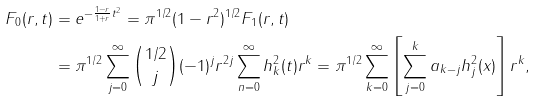Convert formula to latex. <formula><loc_0><loc_0><loc_500><loc_500>F _ { 0 } ( r , t ) & = e ^ { - \frac { 1 - r } { 1 + r } t ^ { 2 } } = \pi ^ { 1 / 2 } ( 1 - r ^ { 2 } ) ^ { 1 / 2 } F _ { 1 } ( r , t ) \\ & = \pi ^ { 1 / 2 } \sum _ { j = 0 } ^ { \infty } \binom { 1 / 2 } { j } ( - 1 ) ^ { j } r ^ { 2 j } \sum _ { n = 0 } ^ { \infty } h _ { k } ^ { 2 } ( t ) r ^ { k } = \pi ^ { 1 / 2 } \sum _ { k = 0 } ^ { \infty } \left [ \sum _ { j = 0 } ^ { k } a _ { k - j } h _ { j } ^ { 2 } ( x ) \right ] r ^ { k } ,</formula> 